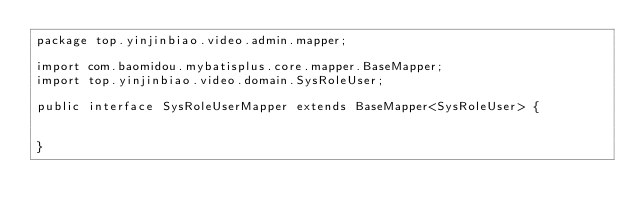Convert code to text. <code><loc_0><loc_0><loc_500><loc_500><_Java_>package top.yinjinbiao.video.admin.mapper;

import com.baomidou.mybatisplus.core.mapper.BaseMapper;
import top.yinjinbiao.video.domain.SysRoleUser;

public interface SysRoleUserMapper extends BaseMapper<SysRoleUser> {


}</code> 